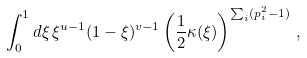<formula> <loc_0><loc_0><loc_500><loc_500>\int _ { 0 } ^ { 1 } d \xi \, \xi ^ { u - 1 } ( 1 - \xi ) ^ { v - 1 } \left ( \frac { 1 } { 2 } \kappa ( \xi ) \right ) ^ { \sum _ { i } ( p _ { i } ^ { 2 } - 1 ) } \, ,</formula> 